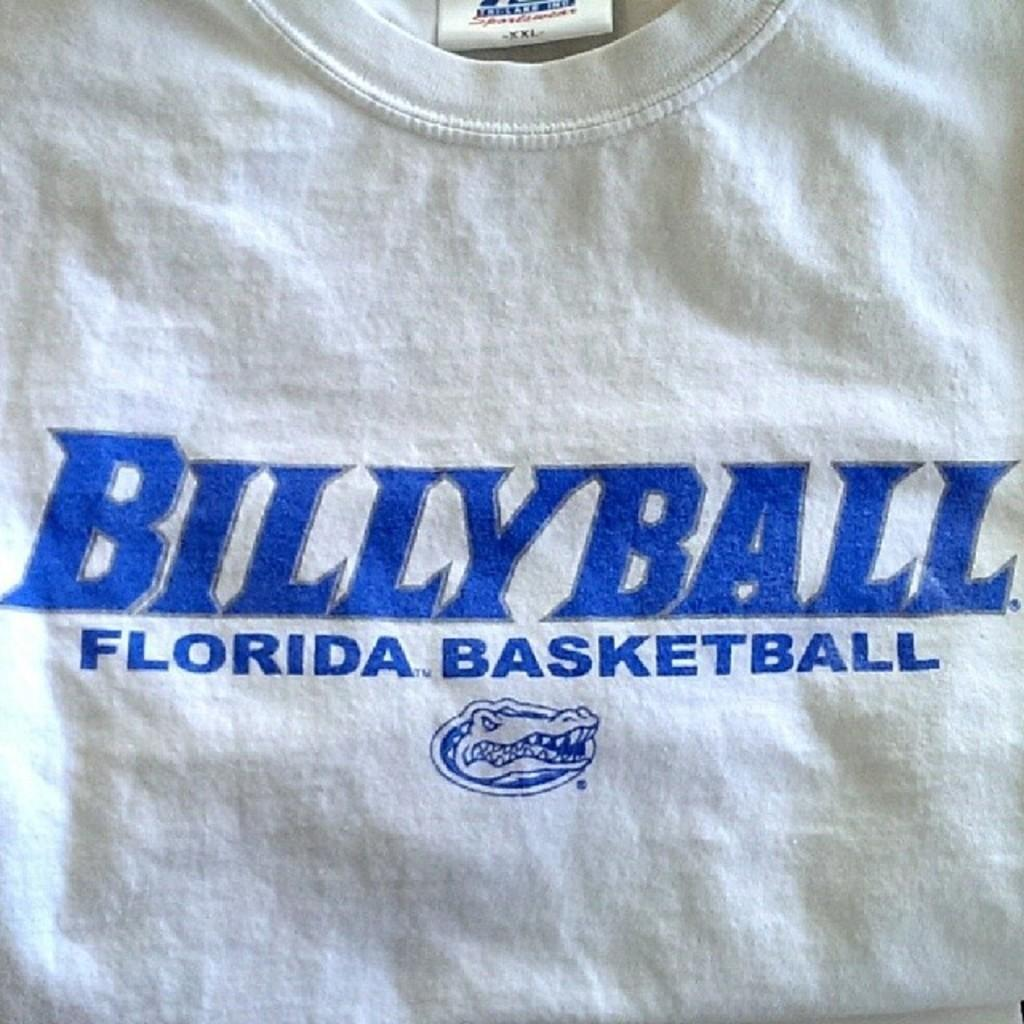Provide a one-sentence caption for the provided image. The white t shirt is the Billy Ball team. 